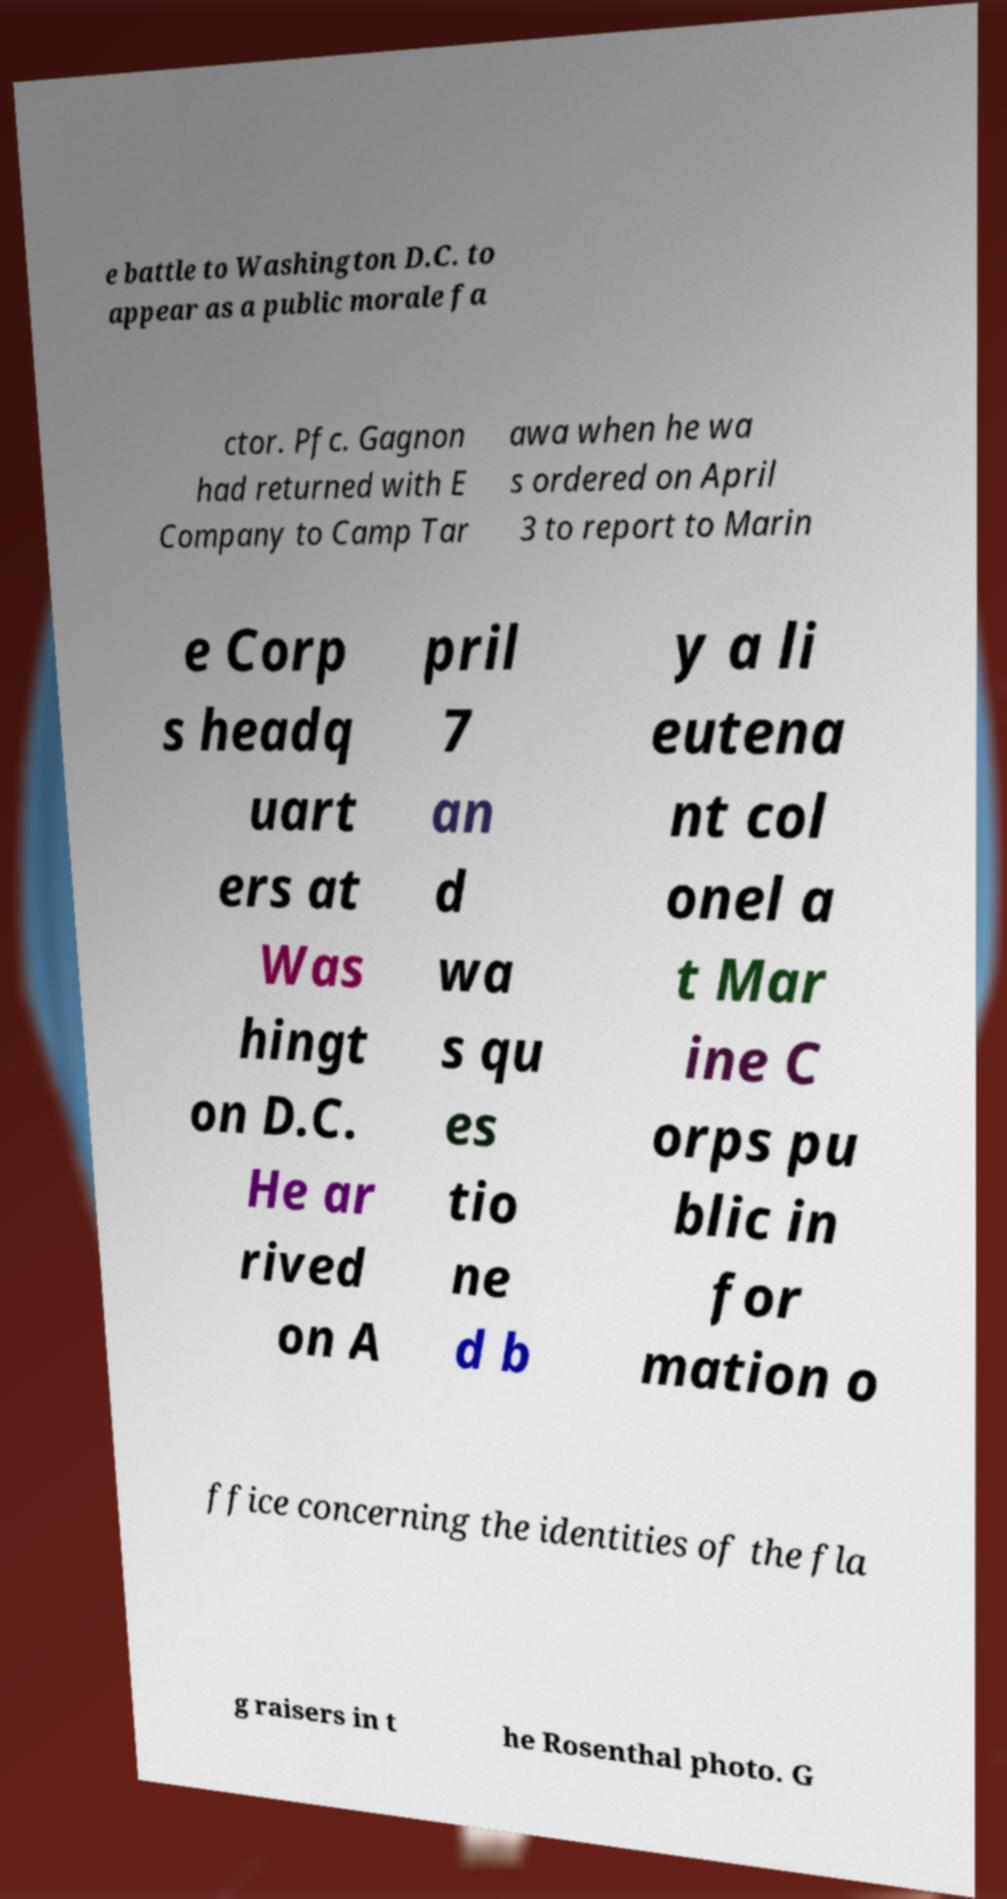Can you accurately transcribe the text from the provided image for me? e battle to Washington D.C. to appear as a public morale fa ctor. Pfc. Gagnon had returned with E Company to Camp Tar awa when he wa s ordered on April 3 to report to Marin e Corp s headq uart ers at Was hingt on D.C. He ar rived on A pril 7 an d wa s qu es tio ne d b y a li eutena nt col onel a t Mar ine C orps pu blic in for mation o ffice concerning the identities of the fla g raisers in t he Rosenthal photo. G 